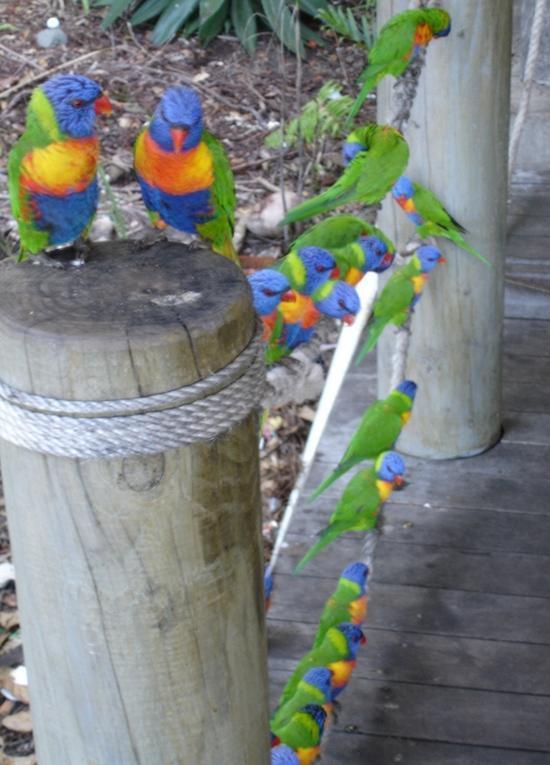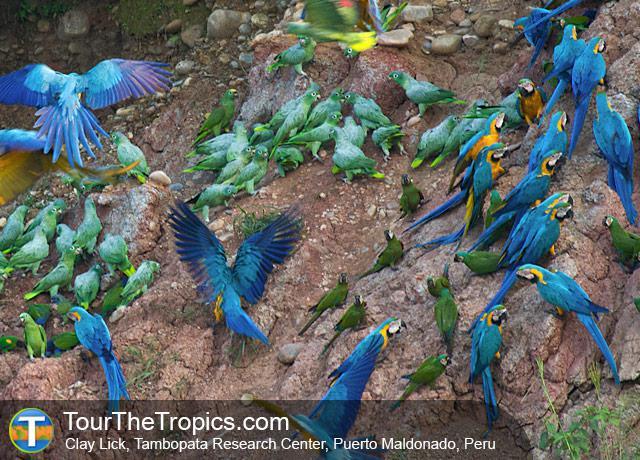The first image is the image on the left, the second image is the image on the right. For the images displayed, is the sentence "There are at least two birds in the image on the left." factually correct? Answer yes or no. Yes. The first image is the image on the left, the second image is the image on the right. Examine the images to the left and right. Is the description "At least eight colorful birds are gathered together, each having a blue head." accurate? Answer yes or no. Yes. 